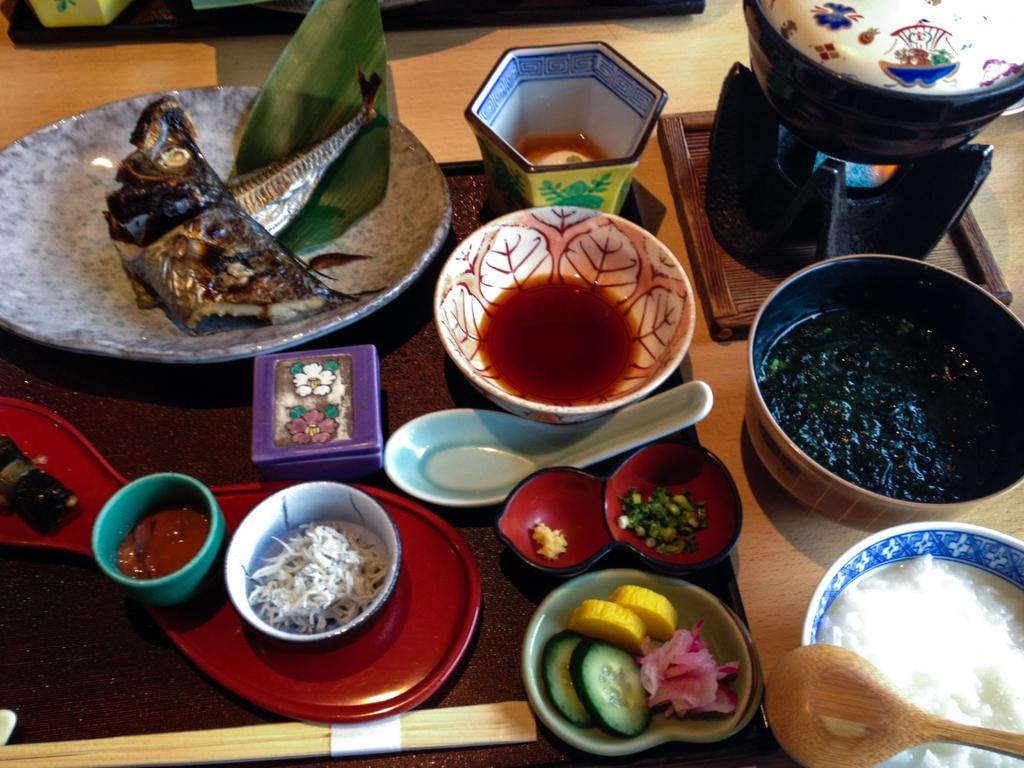What type of objects can be seen in the image? There are food items in the image. How are the food items arranged or contained? The food items are in bowls. Where are the bowls with food items located? The bowls are on a table. What type of ring can be seen on the moon in the image? There is no ring or moon present in the image; it only features food items in bowls on a table. 